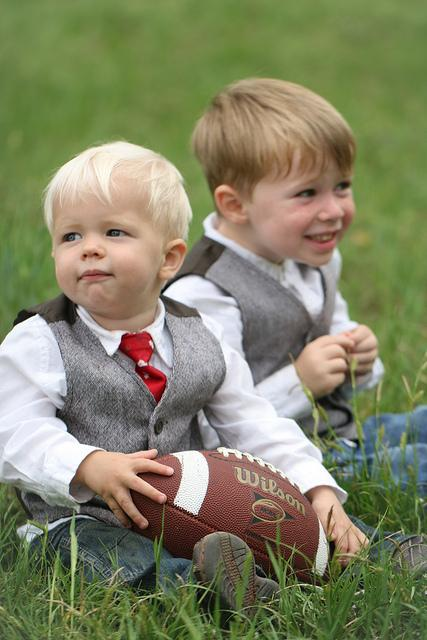What British sport could this ball be used for? rugby 